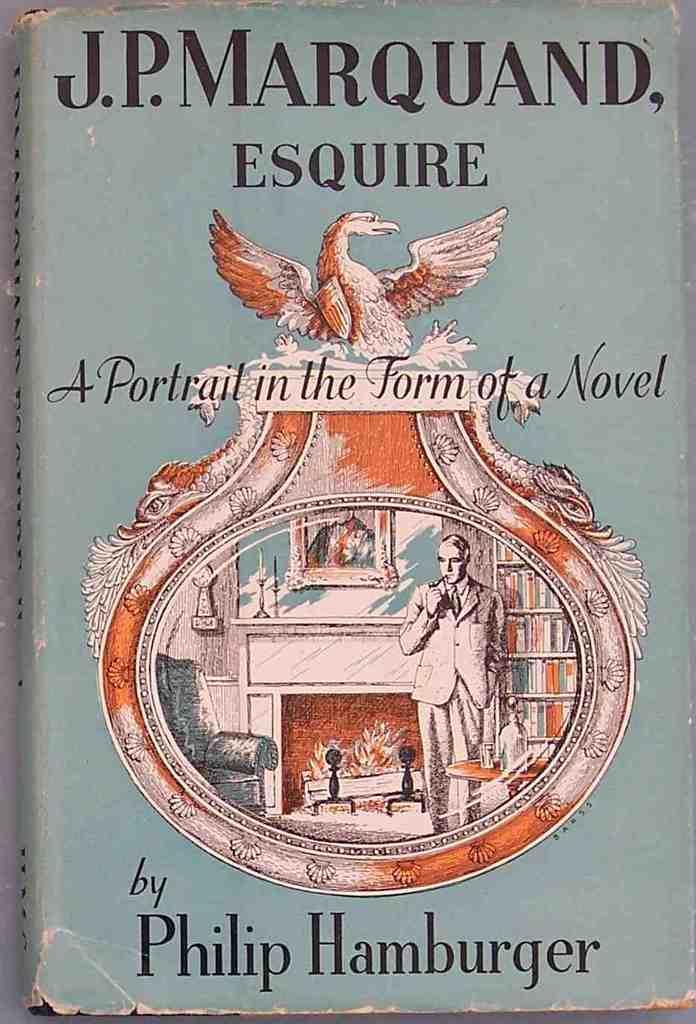Describe this image in one or two sentences. This is the picture of a book. In the front page there is a image of a room. Inside the room there is a man , fireplace, chair, book rack , on a table bottle ,glasses are there. On the wall there is a painting. On the top there is a bird. 